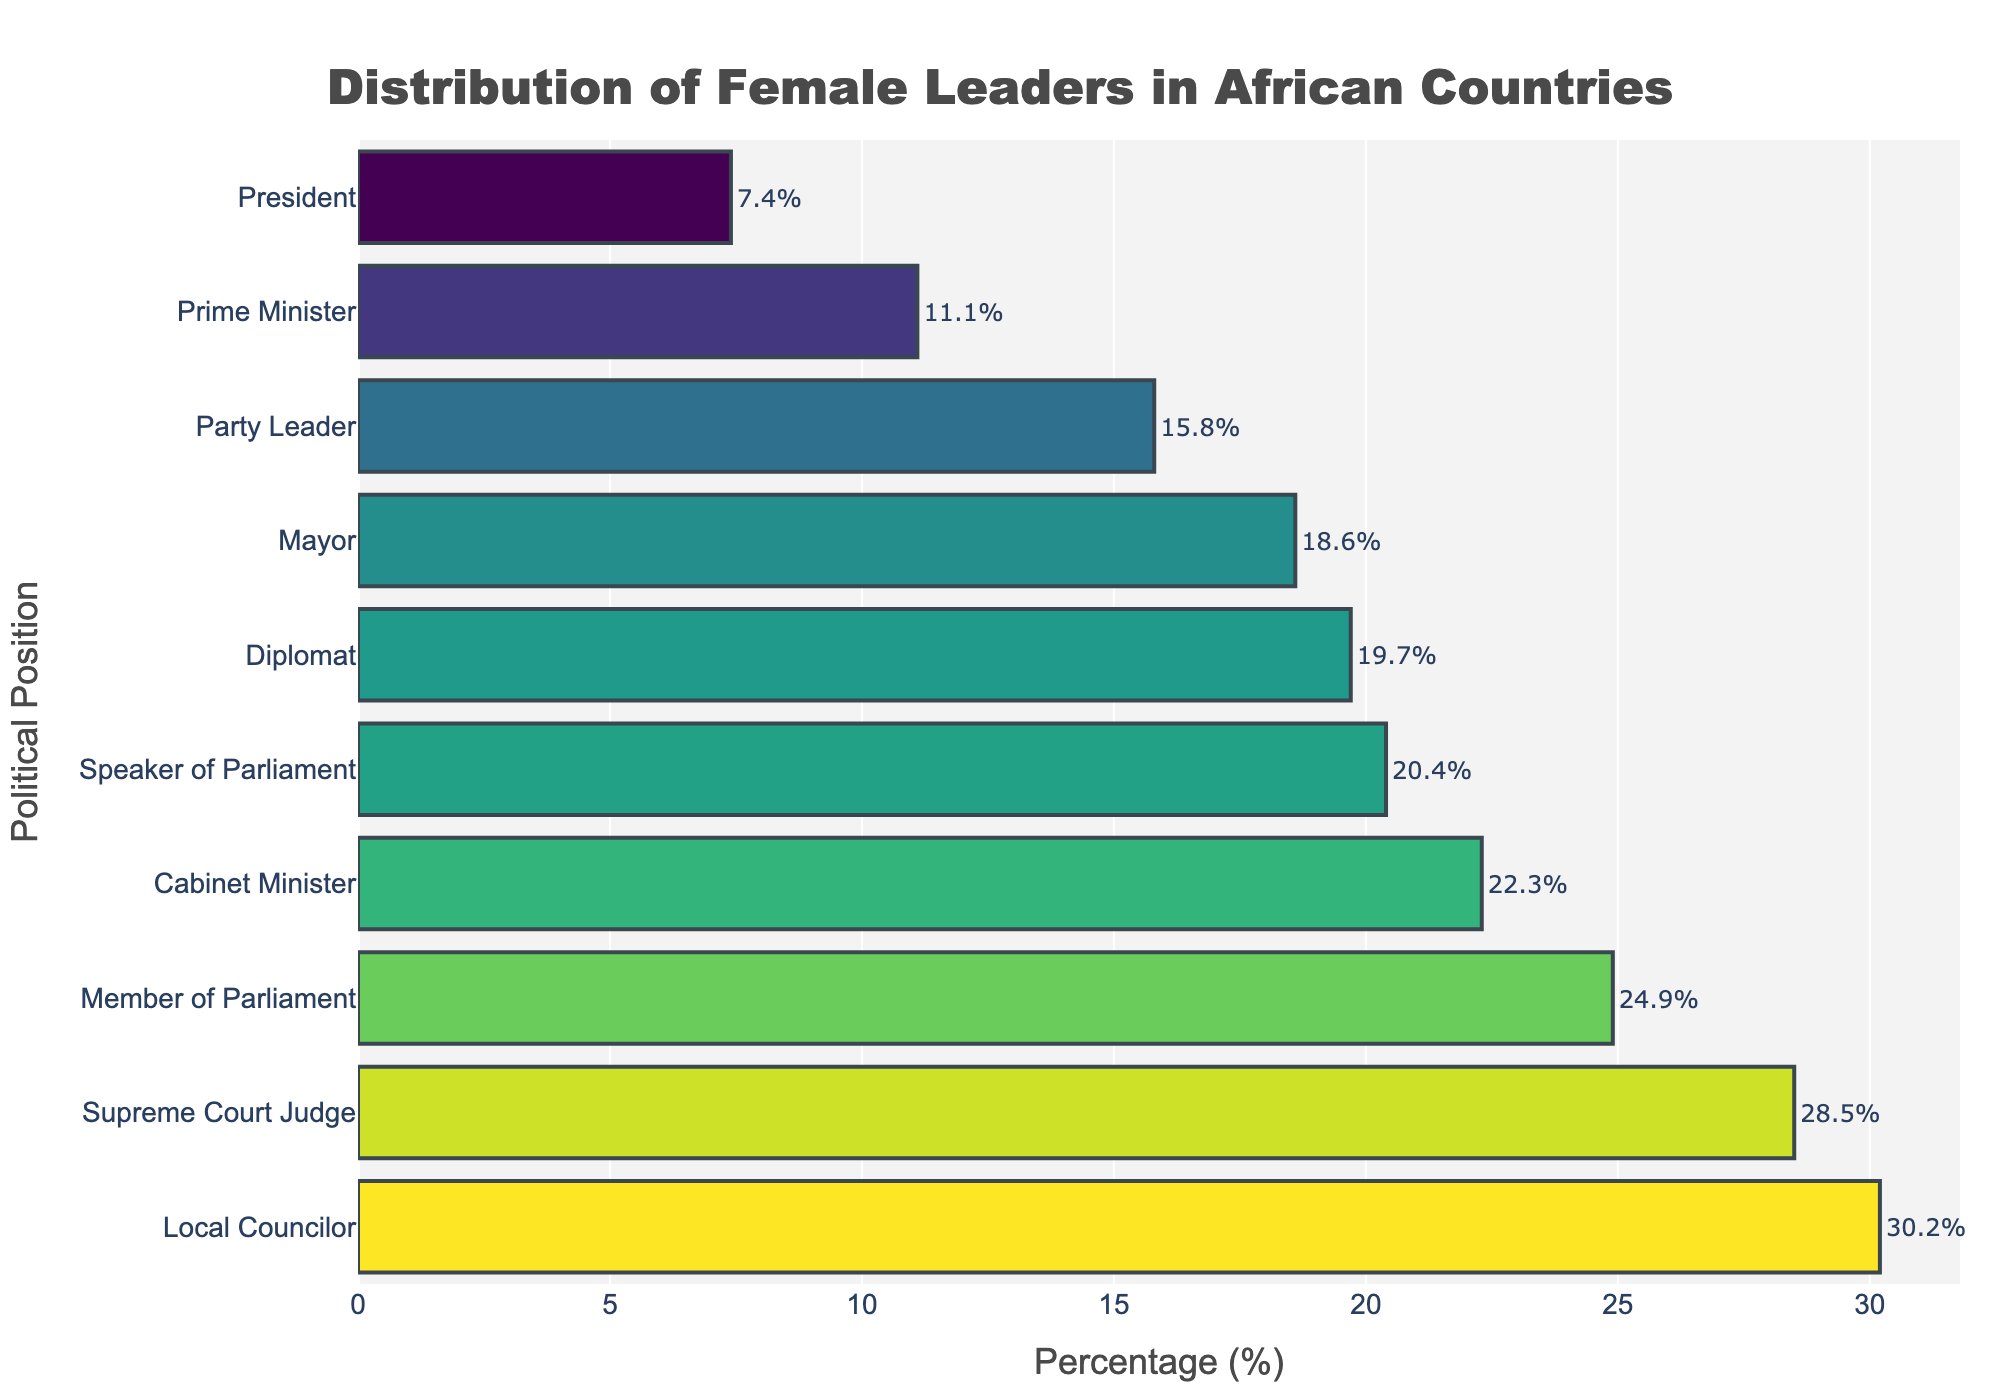Which political position has the highest percentage of female leaders? Look at the bar with the highest length, which is "Local Councilor" with a percentage of 30.2%.
Answer: Local Councilor Which political position has the lowest percentage of female leaders? Look at the bar with the shortest length, which is "President" with a percentage of 7.4%.
Answer: President How much higher is the percentage of female Members of Parliament compared to female Party Leaders? The percentage of female Members of Parliament is 24.9%, and for female Party Leaders, it is 15.8%. The difference is 24.9% - 15.8% = 9.1%.
Answer: 9.1% What is the average percentage of female leaders for Prime Minister, Speaker of Parliament, and Mayor? Add the percentages for Prime Minister (11.1%), Speaker of Parliament (20.4%), and Mayor (18.6%), which totals 50.1%. Divide by 3 to find the average: 50.1% / 3 = 16.7%.
Answer: 16.7% Which categories have a higher percentage of female leaders than female Cabinet Ministers? Female Cabinet Ministers have a percentage of 22.3%. Categories with higher percentages are Local Councilors (30.2%), Supreme Court Judges (28.5%), and Members of Parliament (24.9%).
Answer: Local Councilors, Supreme Court Judges, Members of Parliament By how many percentage points does the percentage of female Supreme Court Judges exceed that of female Diplomat? The percentage for female Supreme Court Judges is 28.5%, and for female Diplomats, it is 19.7%. The difference is 28.5% - 19.7% = 8.8%.
Answer: 8.8% Is the percentage of female Mayors higher than that of female Party Leaders? The percentage of female Mayors (18.6%) is compared to that of female Party Leaders (15.8%). Since 18.6% > 15.8%, the answer is yes.
Answer: Yes What is the sum of percentages for female Presidents and female Prime Ministers? Add the percentages of female Presidents (7.4%) and female Prime Ministers (11.1%), resulting in 7.4% + 11.1% = 18.5%.
Answer: 18.5% Which position is closest in percentage to female Diplomats? The position with the closest percentage to female Diplomats (19.7%) is "Speaker of Parliament" at 20.4%.
Answer: Speaker of Parliament What is the range of percentages for female leaders across all listed positions? The highest percentage is for Local Councilors (30.2%) and the lowest is for Presidents (7.4%). The range is 30.2% - 7.4% = 22.8%.
Answer: 22.8% 